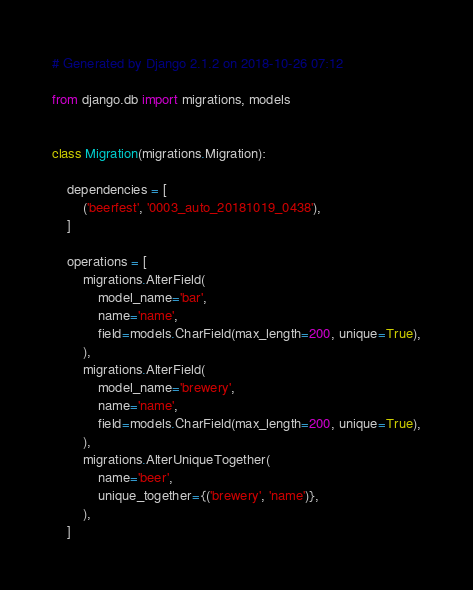<code> <loc_0><loc_0><loc_500><loc_500><_Python_># Generated by Django 2.1.2 on 2018-10-26 07:12

from django.db import migrations, models


class Migration(migrations.Migration):

    dependencies = [
        ('beerfest', '0003_auto_20181019_0438'),
    ]

    operations = [
        migrations.AlterField(
            model_name='bar',
            name='name',
            field=models.CharField(max_length=200, unique=True),
        ),
        migrations.AlterField(
            model_name='brewery',
            name='name',
            field=models.CharField(max_length=200, unique=True),
        ),
        migrations.AlterUniqueTogether(
            name='beer',
            unique_together={('brewery', 'name')},
        ),
    ]
</code> 